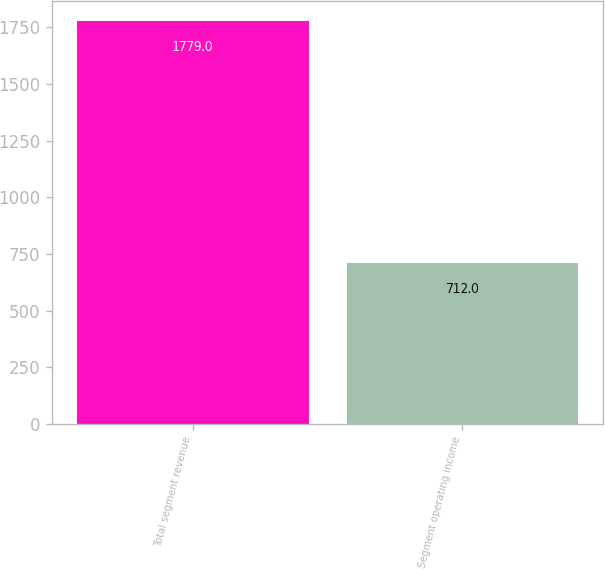Convert chart. <chart><loc_0><loc_0><loc_500><loc_500><bar_chart><fcel>Total segment revenue<fcel>Segment operating income<nl><fcel>1779<fcel>712<nl></chart> 